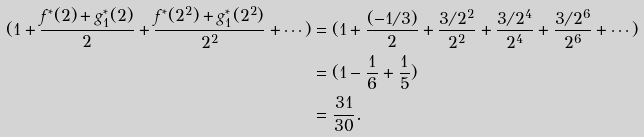<formula> <loc_0><loc_0><loc_500><loc_500>( 1 + \frac { f ^ { * } ( 2 ) + g _ { 1 } ^ { * } ( 2 ) } { 2 } + \frac { f ^ { * } ( 2 ^ { 2 } ) + g _ { 1 } ^ { * } ( 2 ^ { 2 } ) } { 2 ^ { 2 } } + \cdots ) & = ( 1 + \frac { ( - 1 / 3 ) } { 2 } + \frac { 3 / 2 ^ { 2 } } { 2 ^ { 2 } } + \frac { 3 / 2 ^ { 4 } } { 2 ^ { 4 } } + \frac { 3 / 2 ^ { 6 } } { 2 ^ { 6 } } + \cdots ) \\ & = ( 1 - \frac { 1 } { 6 } + \frac { 1 } { 5 } ) \\ & = \frac { 3 1 } { 3 0 } .</formula> 